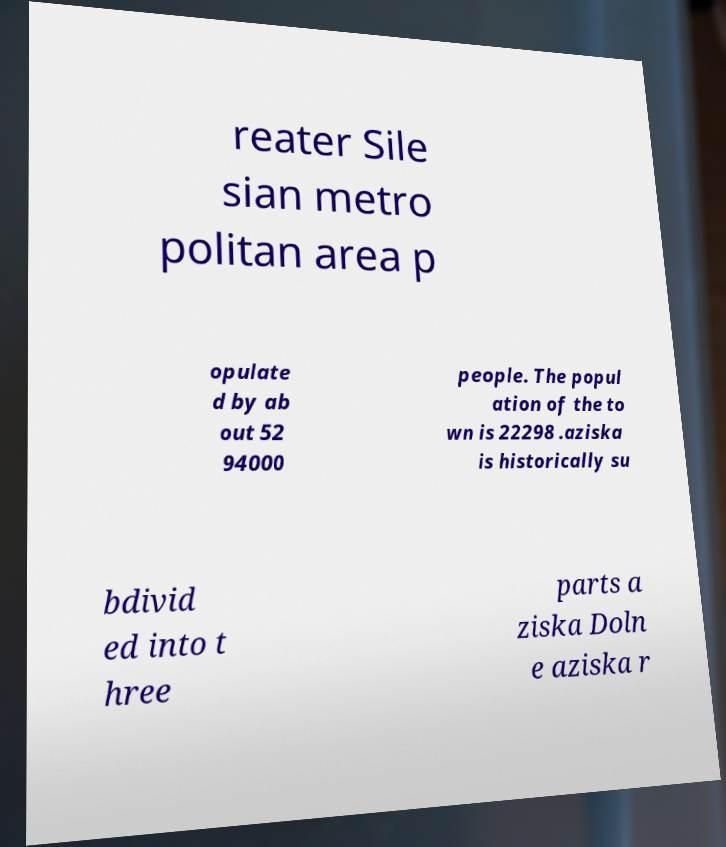What messages or text are displayed in this image? I need them in a readable, typed format. reater Sile sian metro politan area p opulate d by ab out 52 94000 people. The popul ation of the to wn is 22298 .aziska is historically su bdivid ed into t hree parts a ziska Doln e aziska r 